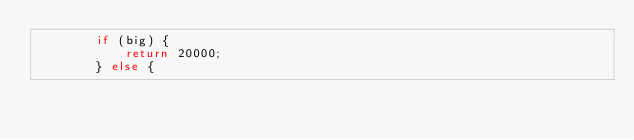Convert code to text. <code><loc_0><loc_0><loc_500><loc_500><_Java_>        if (big) {
            return 20000;
        } else {</code> 